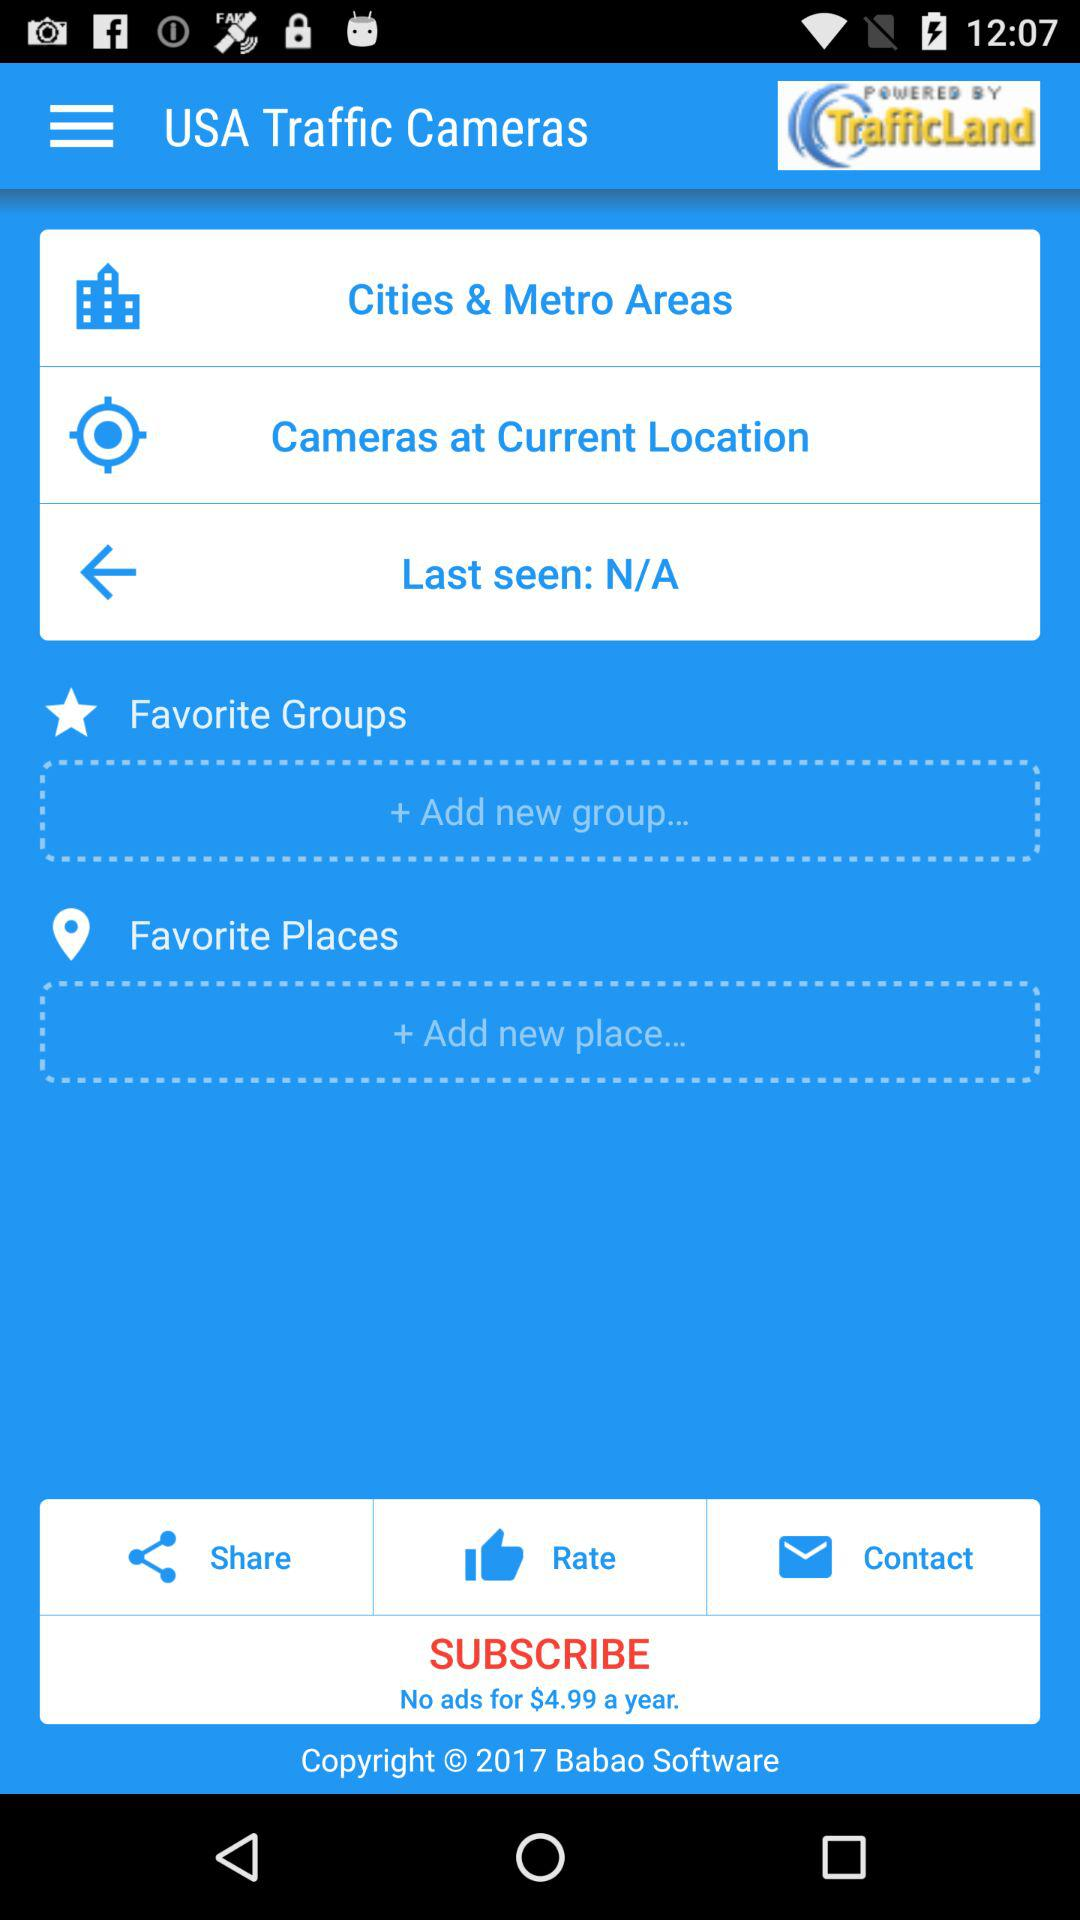What is the cost of the yearly subscription plan? The cost of the yearly subscription plan is $4.99. 